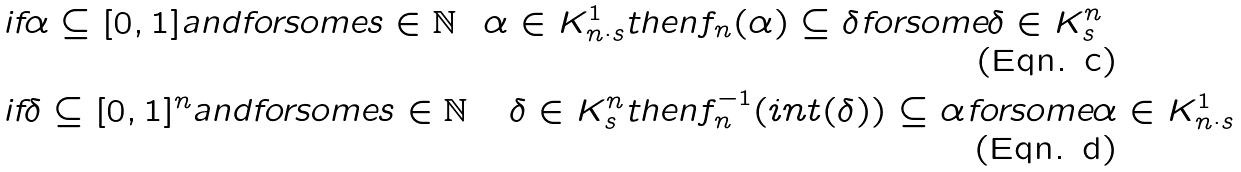<formula> <loc_0><loc_0><loc_500><loc_500>& \text {if} \alpha \subseteq [ 0 , 1 ] \text {andforsome} s \in \mathbb { N } & \alpha \in K ^ { 1 } _ { n \cdot s } & \text {then} f _ { n } ( \alpha ) \subseteq \delta \text {forsome} \delta \in K ^ { n } _ { s } \\ & \text {if} \delta \subseteq [ 0 , 1 ] ^ { n } \text {andforsome} s \in \mathbb { N } & \delta \in K ^ { n } _ { s } & \text {then} f _ { n } ^ { - 1 } ( i n t ( \delta ) ) \subseteq \alpha \text {forsome} \alpha \in K ^ { 1 } _ { n \cdot s }</formula> 